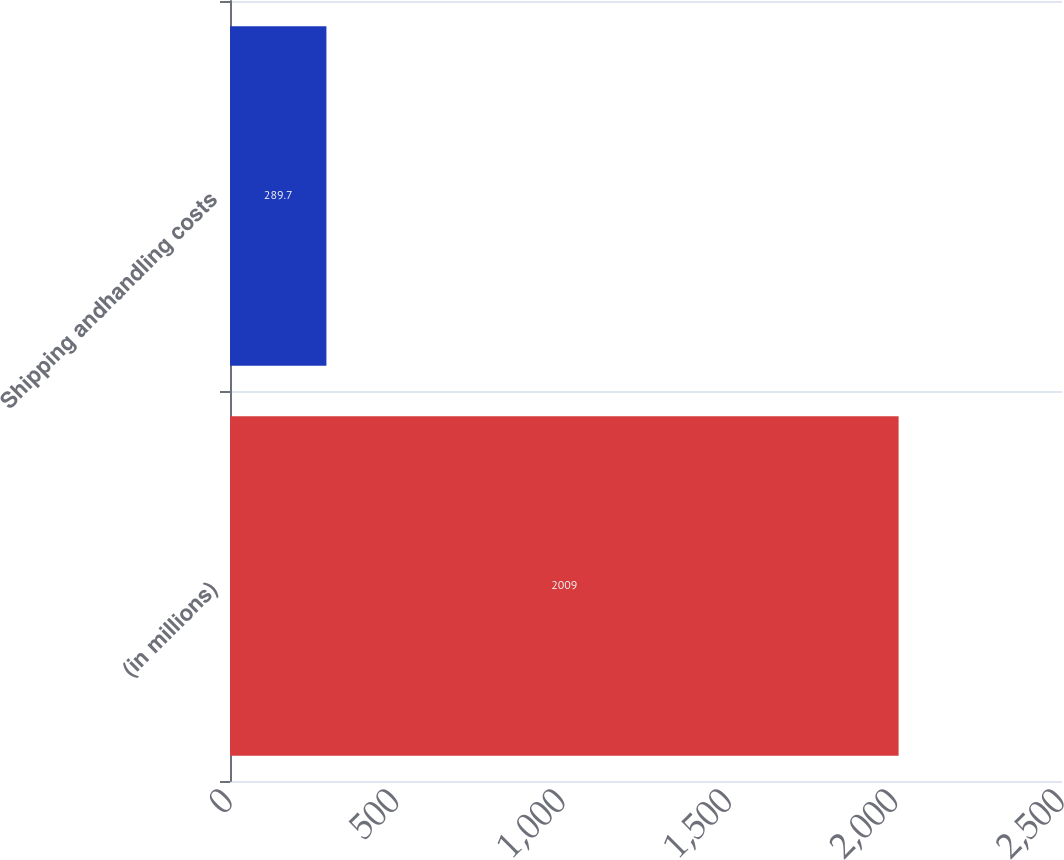Convert chart. <chart><loc_0><loc_0><loc_500><loc_500><bar_chart><fcel>(in millions)<fcel>Shipping andhandling costs<nl><fcel>2009<fcel>289.7<nl></chart> 